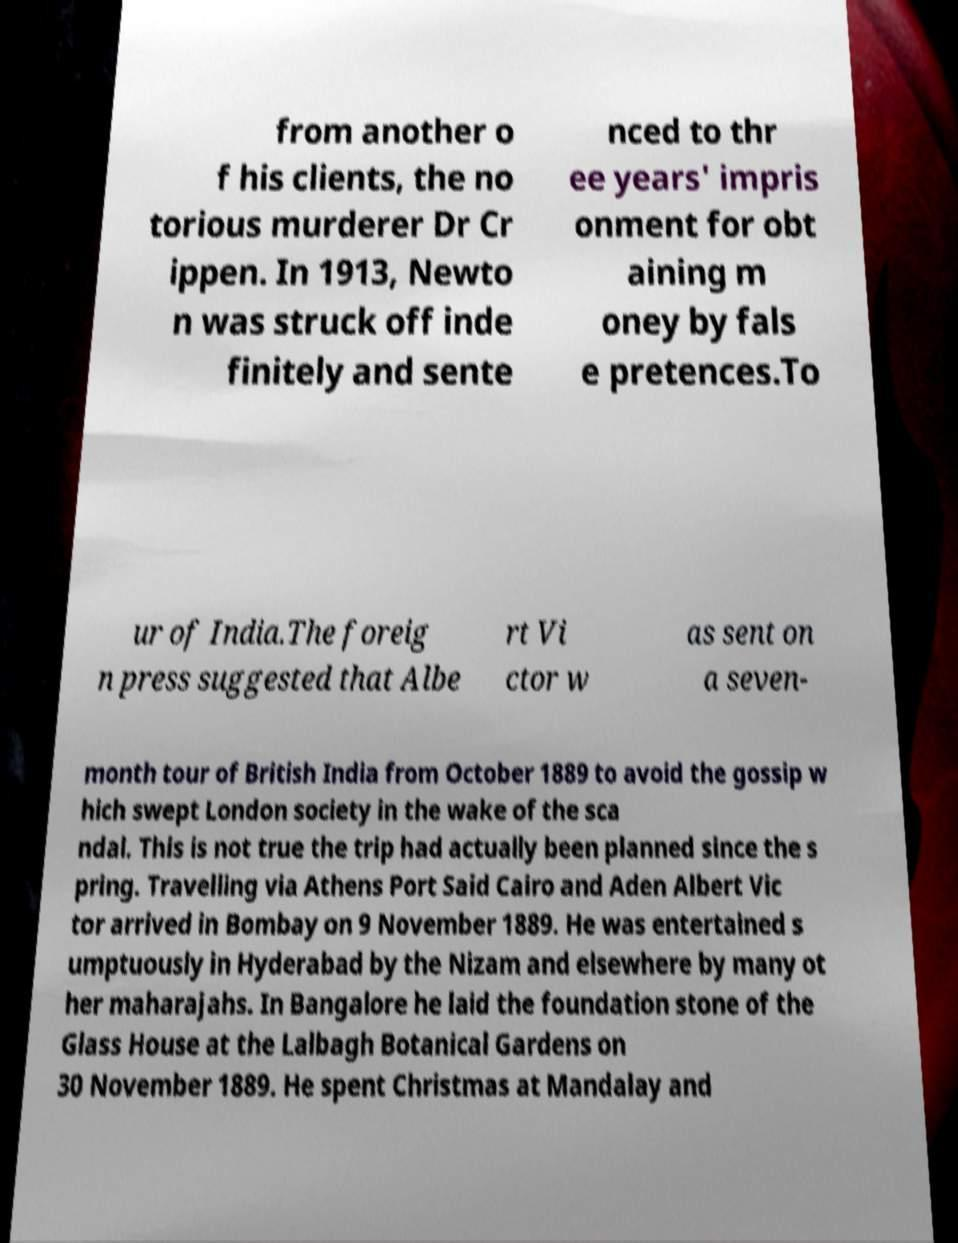What messages or text are displayed in this image? I need them in a readable, typed format. from another o f his clients, the no torious murderer Dr Cr ippen. In 1913, Newto n was struck off inde finitely and sente nced to thr ee years' impris onment for obt aining m oney by fals e pretences.To ur of India.The foreig n press suggested that Albe rt Vi ctor w as sent on a seven- month tour of British India from October 1889 to avoid the gossip w hich swept London society in the wake of the sca ndal. This is not true the trip had actually been planned since the s pring. Travelling via Athens Port Said Cairo and Aden Albert Vic tor arrived in Bombay on 9 November 1889. He was entertained s umptuously in Hyderabad by the Nizam and elsewhere by many ot her maharajahs. In Bangalore he laid the foundation stone of the Glass House at the Lalbagh Botanical Gardens on 30 November 1889. He spent Christmas at Mandalay and 